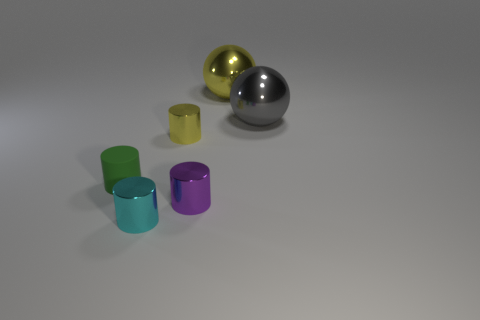How many other objects are there of the same size as the purple shiny object?
Your answer should be very brief. 3. What number of things are either tiny yellow blocks or small metal things that are to the right of the cyan cylinder?
Your answer should be compact. 2. Is the number of green things less than the number of metal things?
Your answer should be compact. Yes. There is a small metallic object on the right side of the small object that is behind the rubber cylinder; what color is it?
Your response must be concise. Purple. What material is the small yellow object that is the same shape as the small purple object?
Give a very brief answer. Metal. What number of shiny things are either big yellow things or small yellow objects?
Make the answer very short. 2. Do the small cylinder in front of the small purple cylinder and the green object on the left side of the tiny purple shiny thing have the same material?
Make the answer very short. No. Are any purple shiny objects visible?
Provide a succinct answer. Yes. There is a tiny shiny thing that is to the right of the tiny yellow metallic cylinder; is its shape the same as the yellow object that is behind the tiny yellow metallic object?
Ensure brevity in your answer.  No. Is there a yellow sphere that has the same material as the small cyan object?
Offer a terse response. Yes. 